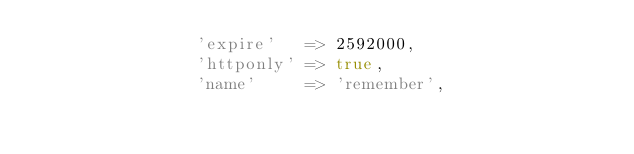<code> <loc_0><loc_0><loc_500><loc_500><_PHP_>				'expire'   => 2592000,
				'httponly' => true,
				'name'     => 'remember',</code> 